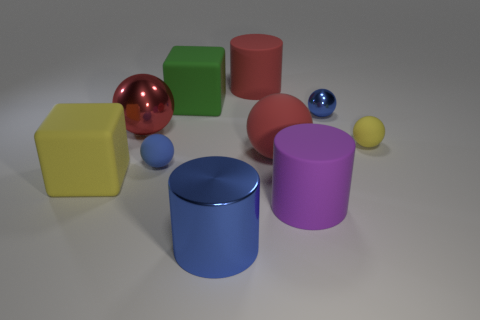Can you tell which object is the largest and which is the smallest? Judging by their relative sizes in the image, the red cylinder appears to be the largest object, and the small yellow ball positions it as the smallest. 